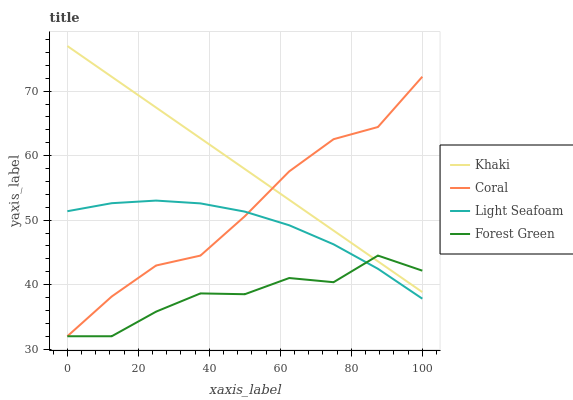Does Forest Green have the minimum area under the curve?
Answer yes or no. Yes. Does Khaki have the maximum area under the curve?
Answer yes or no. Yes. Does Khaki have the minimum area under the curve?
Answer yes or no. No. Does Forest Green have the maximum area under the curve?
Answer yes or no. No. Is Khaki the smoothest?
Answer yes or no. Yes. Is Forest Green the roughest?
Answer yes or no. Yes. Is Forest Green the smoothest?
Answer yes or no. No. Is Khaki the roughest?
Answer yes or no. No. Does Khaki have the lowest value?
Answer yes or no. No. Does Khaki have the highest value?
Answer yes or no. Yes. Does Forest Green have the highest value?
Answer yes or no. No. Is Light Seafoam less than Khaki?
Answer yes or no. Yes. Is Khaki greater than Light Seafoam?
Answer yes or no. Yes. Does Light Seafoam intersect Khaki?
Answer yes or no. No. 